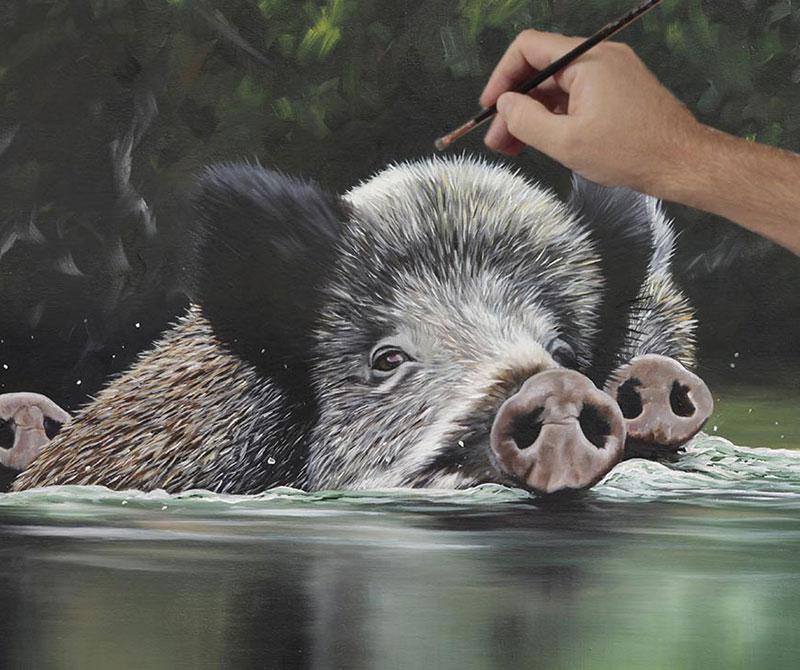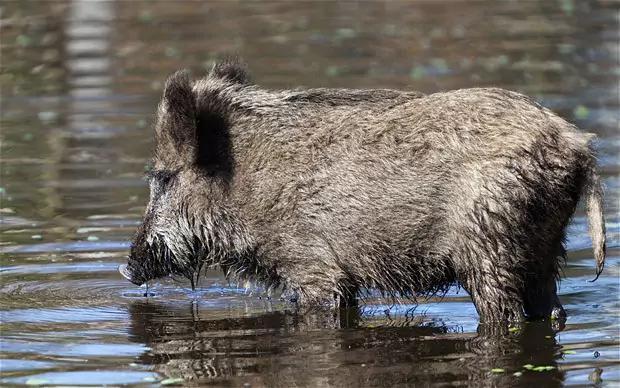The first image is the image on the left, the second image is the image on the right. Evaluate the accuracy of this statement regarding the images: "The left image contains one wild pig swimming leftward, with tall grass on the water's edge behind him.". Is it true? Answer yes or no. No. 